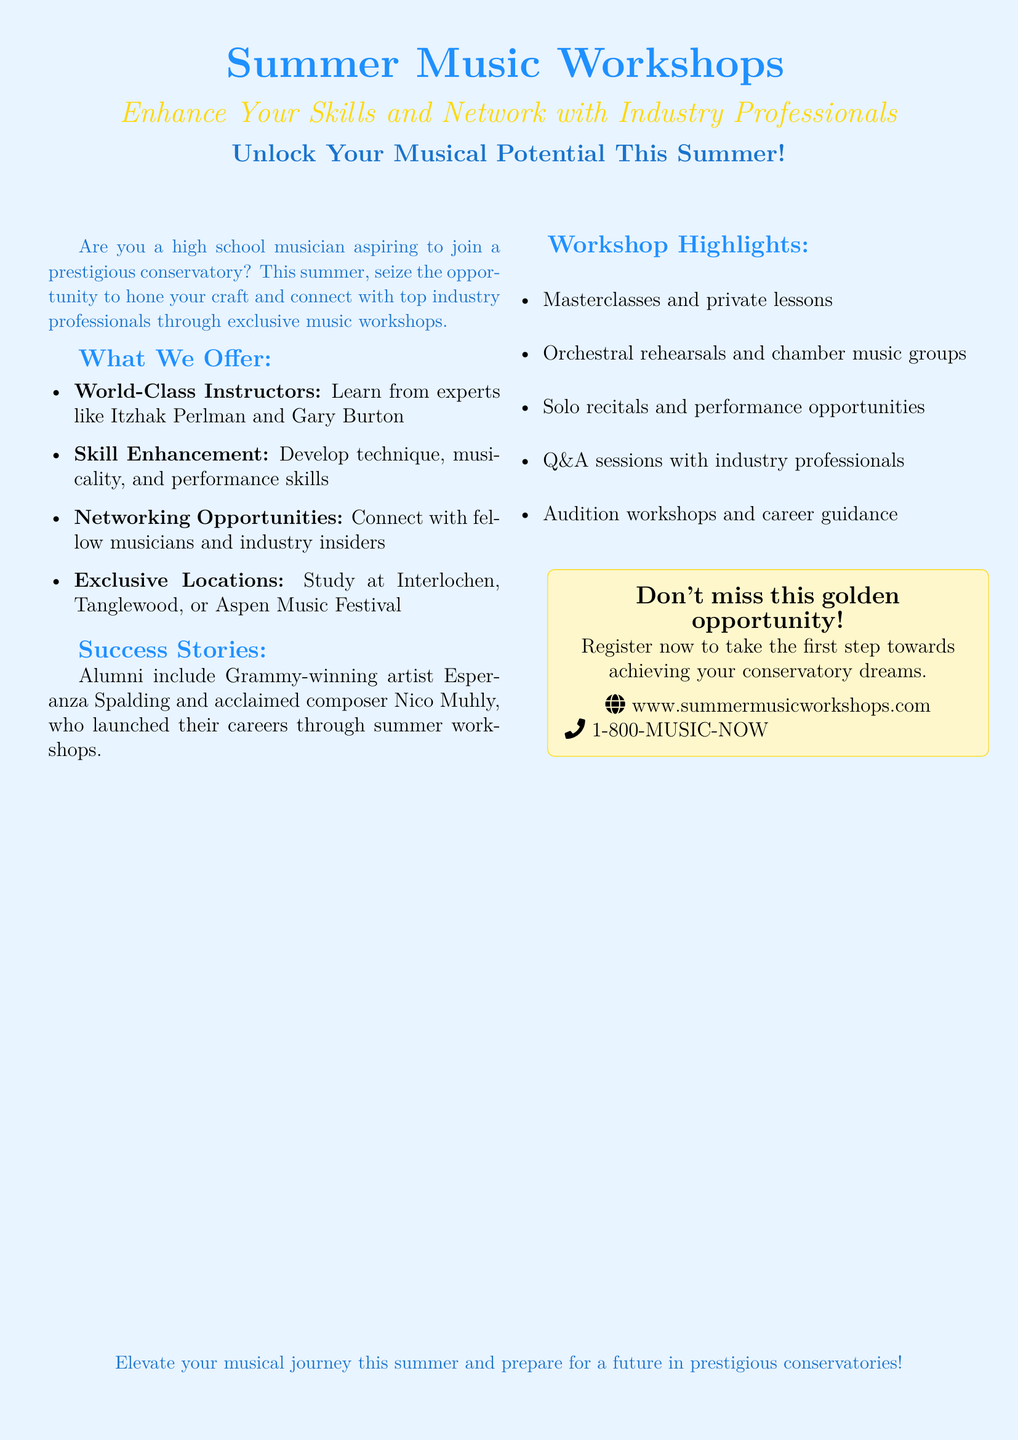What are the names of two world-class instructors? The document lists Itzhak Perlman and Gary Burton as world-class instructors.
Answer: Itzhak Perlman and Gary Burton What is the primary goal of the summer music workshops? The primary goal is to enhance skills and network with industry professionals.
Answer: Enhance skills and network Where do the workshops take place? Exclusive locations for the workshops include Interlochen, Tanglewood, and Aspen Music Festival.
Answer: Interlochen, Tanglewood, Aspen Music Festival Who is an alumnus of the workshops that is a Grammy-winning artist? The document mentions Esperanza Spalding as a Grammy-winning artist who attended the workshops.
Answer: Esperanza Spalding What type of sessions are included in the workshop highlights? The highlights mention masterclasses, private lessons, orchestral rehearsals, and more.
Answer: Masterclasses and private lessons How can participants register for the workshops? Participants can register through the website provided in the document.
Answer: www.summermusicworkshops.com What special service is offered for aspiring musicians? The workshops include audition workshops and career guidance specifically for aspiring musicians.
Answer: Audition workshops and career guidance Which two musicians are highlighted in the success stories? The document highlights Esperanza Spalding and Nico Muhly as successful alumni.
Answer: Esperanza Spalding and Nico Muhly 